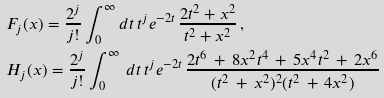Convert formula to latex. <formula><loc_0><loc_0><loc_500><loc_500>& F _ { j } ( x ) = \frac { 2 ^ { j } } { j ! } \int _ { 0 } ^ { \infty } d t \, t ^ { j } e ^ { - 2 t } \, \frac { 2 t ^ { 2 } + x ^ { 2 } } { t ^ { 2 } + x ^ { 2 } } \, , \\ & H _ { j } ( x ) = \frac { 2 ^ { j } } { j ! } \int _ { 0 } ^ { \infty } \, d t \, t ^ { j } e ^ { - 2 t } \, \frac { 2 t ^ { 6 } \, + \, 8 x ^ { 2 } t ^ { 4 } \, + \, 5 x ^ { 4 } t ^ { 2 } \, + \, 2 x ^ { 6 } } { ( t ^ { 2 } \, + \, x ^ { 2 } ) ^ { 2 } ( t ^ { 2 } \, + \, 4 x ^ { 2 } ) }</formula> 